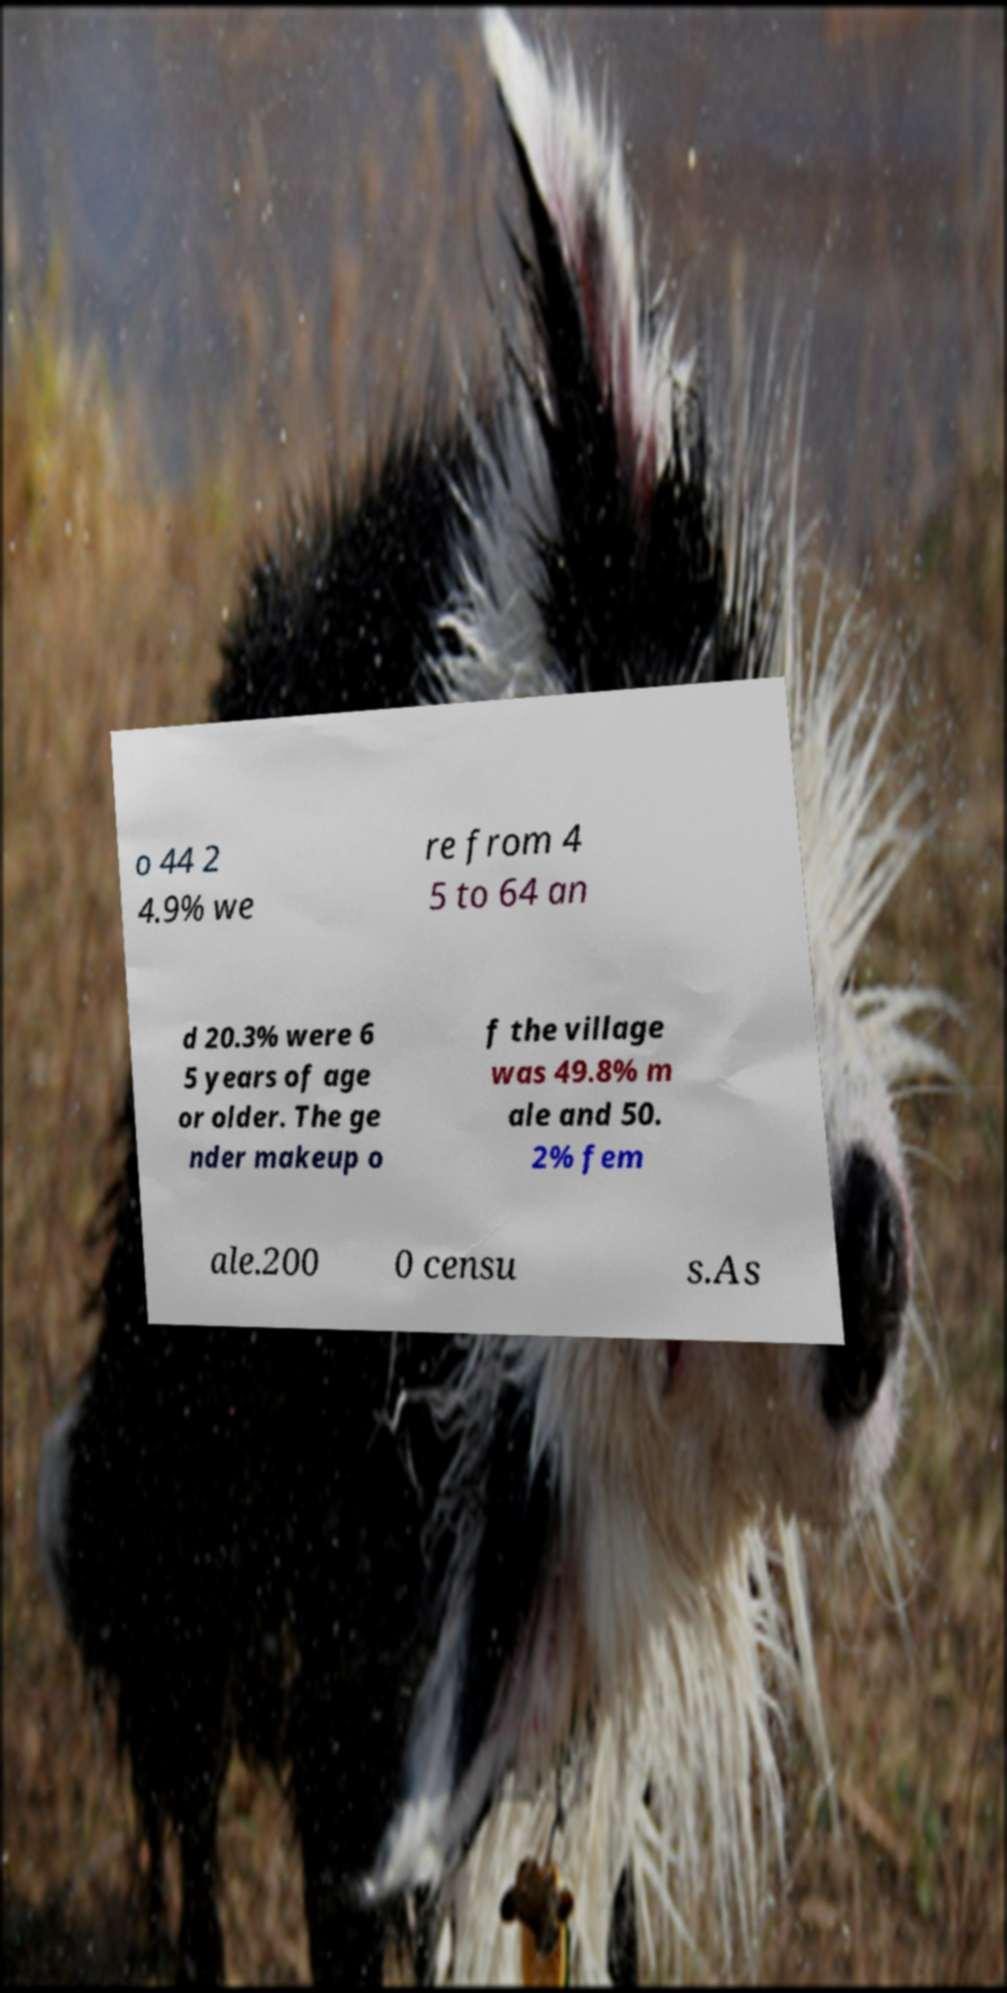What messages or text are displayed in this image? I need them in a readable, typed format. o 44 2 4.9% we re from 4 5 to 64 an d 20.3% were 6 5 years of age or older. The ge nder makeup o f the village was 49.8% m ale and 50. 2% fem ale.200 0 censu s.As 